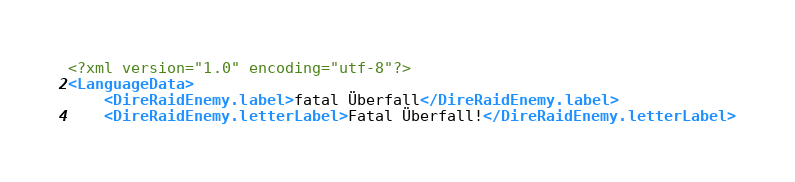Convert code to text. <code><loc_0><loc_0><loc_500><loc_500><_XML_><?xml version="1.0" encoding="utf-8"?>
<LanguageData>
    <DireRaidEnemy.label>fatal Überfall</DireRaidEnemy.label>
    <DireRaidEnemy.letterLabel>Fatal Überfall!</DireRaidEnemy.letterLabel></code> 